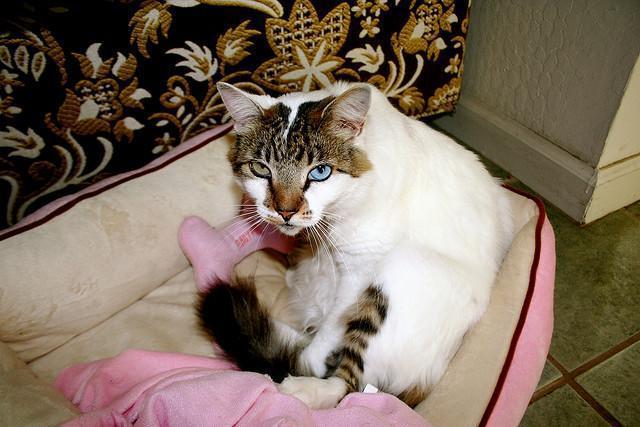How many couches are visible?
Give a very brief answer. 2. How many chairs are there?
Give a very brief answer. 0. 